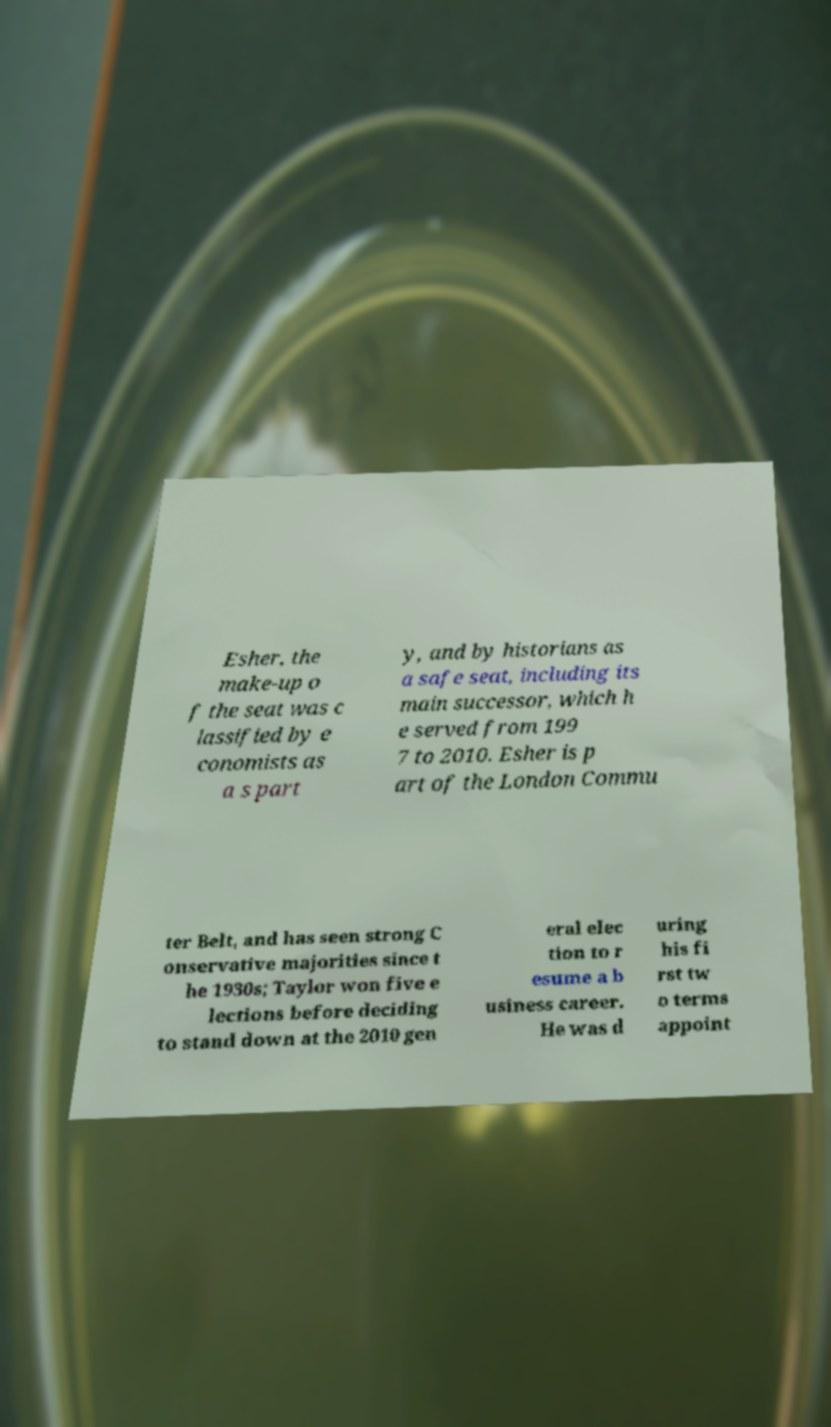Please identify and transcribe the text found in this image. Esher, the make-up o f the seat was c lassified by e conomists as a s part y, and by historians as a safe seat, including its main successor, which h e served from 199 7 to 2010. Esher is p art of the London Commu ter Belt, and has seen strong C onservative majorities since t he 1930s; Taylor won five e lections before deciding to stand down at the 2010 gen eral elec tion to r esume a b usiness career. He was d uring his fi rst tw o terms appoint 